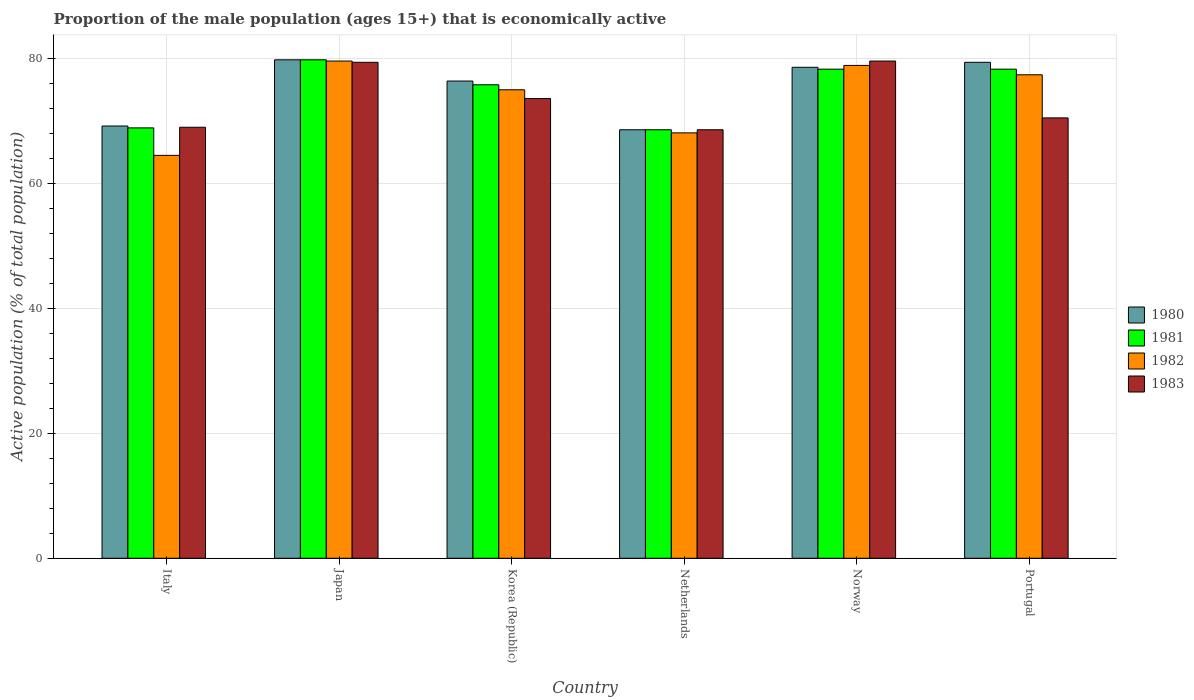How many groups of bars are there?
Offer a very short reply. 6. What is the label of the 6th group of bars from the left?
Make the answer very short. Portugal. In how many cases, is the number of bars for a given country not equal to the number of legend labels?
Ensure brevity in your answer.  0. What is the proportion of the male population that is economically active in 1981 in Norway?
Your response must be concise. 78.3. Across all countries, what is the maximum proportion of the male population that is economically active in 1981?
Offer a terse response. 79.8. Across all countries, what is the minimum proportion of the male population that is economically active in 1983?
Provide a short and direct response. 68.6. In which country was the proportion of the male population that is economically active in 1982 maximum?
Provide a short and direct response. Japan. What is the total proportion of the male population that is economically active in 1981 in the graph?
Ensure brevity in your answer.  449.7. What is the difference between the proportion of the male population that is economically active in 1983 in Italy and the proportion of the male population that is economically active in 1981 in Japan?
Provide a short and direct response. -10.8. What is the average proportion of the male population that is economically active in 1980 per country?
Ensure brevity in your answer.  75.33. What is the difference between the proportion of the male population that is economically active of/in 1980 and proportion of the male population that is economically active of/in 1983 in Norway?
Offer a terse response. -1. In how many countries, is the proportion of the male population that is economically active in 1983 greater than 40 %?
Your answer should be compact. 6. What is the ratio of the proportion of the male population that is economically active in 1981 in Italy to that in Norway?
Your answer should be compact. 0.88. Is the proportion of the male population that is economically active in 1980 in Norway less than that in Portugal?
Give a very brief answer. Yes. Is the difference between the proportion of the male population that is economically active in 1980 in Japan and Portugal greater than the difference between the proportion of the male population that is economically active in 1983 in Japan and Portugal?
Give a very brief answer. No. What is the difference between the highest and the second highest proportion of the male population that is economically active in 1982?
Your answer should be compact. -1.5. What is the difference between the highest and the lowest proportion of the male population that is economically active in 1983?
Make the answer very short. 11. Is the sum of the proportion of the male population that is economically active in 1981 in Japan and Netherlands greater than the maximum proportion of the male population that is economically active in 1982 across all countries?
Ensure brevity in your answer.  Yes. What does the 1st bar from the left in Korea (Republic) represents?
Provide a succinct answer. 1980. Is it the case that in every country, the sum of the proportion of the male population that is economically active in 1982 and proportion of the male population that is economically active in 1983 is greater than the proportion of the male population that is economically active in 1980?
Ensure brevity in your answer.  Yes. How many bars are there?
Keep it short and to the point. 24. Are all the bars in the graph horizontal?
Make the answer very short. No. What is the difference between two consecutive major ticks on the Y-axis?
Make the answer very short. 20. Are the values on the major ticks of Y-axis written in scientific E-notation?
Your response must be concise. No. Does the graph contain any zero values?
Your answer should be very brief. No. Does the graph contain grids?
Ensure brevity in your answer.  Yes. Where does the legend appear in the graph?
Offer a very short reply. Center right. What is the title of the graph?
Your answer should be compact. Proportion of the male population (ages 15+) that is economically active. Does "1972" appear as one of the legend labels in the graph?
Keep it short and to the point. No. What is the label or title of the Y-axis?
Keep it short and to the point. Active population (% of total population). What is the Active population (% of total population) in 1980 in Italy?
Offer a terse response. 69.2. What is the Active population (% of total population) of 1981 in Italy?
Your answer should be compact. 68.9. What is the Active population (% of total population) in 1982 in Italy?
Provide a succinct answer. 64.5. What is the Active population (% of total population) of 1983 in Italy?
Offer a terse response. 69. What is the Active population (% of total population) of 1980 in Japan?
Your answer should be very brief. 79.8. What is the Active population (% of total population) in 1981 in Japan?
Your response must be concise. 79.8. What is the Active population (% of total population) of 1982 in Japan?
Keep it short and to the point. 79.6. What is the Active population (% of total population) of 1983 in Japan?
Keep it short and to the point. 79.4. What is the Active population (% of total population) in 1980 in Korea (Republic)?
Offer a very short reply. 76.4. What is the Active population (% of total population) in 1981 in Korea (Republic)?
Make the answer very short. 75.8. What is the Active population (% of total population) of 1983 in Korea (Republic)?
Give a very brief answer. 73.6. What is the Active population (% of total population) of 1980 in Netherlands?
Your answer should be compact. 68.6. What is the Active population (% of total population) in 1981 in Netherlands?
Make the answer very short. 68.6. What is the Active population (% of total population) in 1982 in Netherlands?
Give a very brief answer. 68.1. What is the Active population (% of total population) of 1983 in Netherlands?
Provide a succinct answer. 68.6. What is the Active population (% of total population) in 1980 in Norway?
Your answer should be compact. 78.6. What is the Active population (% of total population) in 1981 in Norway?
Your answer should be compact. 78.3. What is the Active population (% of total population) in 1982 in Norway?
Keep it short and to the point. 78.9. What is the Active population (% of total population) in 1983 in Norway?
Offer a very short reply. 79.6. What is the Active population (% of total population) in 1980 in Portugal?
Your response must be concise. 79.4. What is the Active population (% of total population) of 1981 in Portugal?
Make the answer very short. 78.3. What is the Active population (% of total population) in 1982 in Portugal?
Keep it short and to the point. 77.4. What is the Active population (% of total population) in 1983 in Portugal?
Give a very brief answer. 70.5. Across all countries, what is the maximum Active population (% of total population) in 1980?
Keep it short and to the point. 79.8. Across all countries, what is the maximum Active population (% of total population) in 1981?
Provide a succinct answer. 79.8. Across all countries, what is the maximum Active population (% of total population) of 1982?
Your response must be concise. 79.6. Across all countries, what is the maximum Active population (% of total population) of 1983?
Offer a terse response. 79.6. Across all countries, what is the minimum Active population (% of total population) of 1980?
Your response must be concise. 68.6. Across all countries, what is the minimum Active population (% of total population) of 1981?
Offer a very short reply. 68.6. Across all countries, what is the minimum Active population (% of total population) in 1982?
Ensure brevity in your answer.  64.5. Across all countries, what is the minimum Active population (% of total population) in 1983?
Offer a very short reply. 68.6. What is the total Active population (% of total population) of 1980 in the graph?
Ensure brevity in your answer.  452. What is the total Active population (% of total population) in 1981 in the graph?
Provide a succinct answer. 449.7. What is the total Active population (% of total population) of 1982 in the graph?
Your response must be concise. 443.5. What is the total Active population (% of total population) of 1983 in the graph?
Give a very brief answer. 440.7. What is the difference between the Active population (% of total population) of 1981 in Italy and that in Japan?
Give a very brief answer. -10.9. What is the difference between the Active population (% of total population) of 1982 in Italy and that in Japan?
Offer a very short reply. -15.1. What is the difference between the Active population (% of total population) in 1983 in Italy and that in Japan?
Offer a very short reply. -10.4. What is the difference between the Active population (% of total population) of 1981 in Italy and that in Korea (Republic)?
Offer a very short reply. -6.9. What is the difference between the Active population (% of total population) in 1982 in Italy and that in Korea (Republic)?
Your answer should be compact. -10.5. What is the difference between the Active population (% of total population) of 1983 in Italy and that in Korea (Republic)?
Offer a terse response. -4.6. What is the difference between the Active population (% of total population) in 1980 in Italy and that in Netherlands?
Ensure brevity in your answer.  0.6. What is the difference between the Active population (% of total population) in 1981 in Italy and that in Netherlands?
Your response must be concise. 0.3. What is the difference between the Active population (% of total population) in 1982 in Italy and that in Netherlands?
Give a very brief answer. -3.6. What is the difference between the Active population (% of total population) of 1980 in Italy and that in Norway?
Ensure brevity in your answer.  -9.4. What is the difference between the Active population (% of total population) of 1981 in Italy and that in Norway?
Your answer should be compact. -9.4. What is the difference between the Active population (% of total population) in 1982 in Italy and that in Norway?
Ensure brevity in your answer.  -14.4. What is the difference between the Active population (% of total population) of 1983 in Italy and that in Norway?
Offer a very short reply. -10.6. What is the difference between the Active population (% of total population) in 1980 in Italy and that in Portugal?
Make the answer very short. -10.2. What is the difference between the Active population (% of total population) in 1981 in Italy and that in Portugal?
Ensure brevity in your answer.  -9.4. What is the difference between the Active population (% of total population) in 1981 in Japan and that in Korea (Republic)?
Provide a succinct answer. 4. What is the difference between the Active population (% of total population) of 1982 in Japan and that in Korea (Republic)?
Provide a short and direct response. 4.6. What is the difference between the Active population (% of total population) of 1980 in Japan and that in Netherlands?
Provide a short and direct response. 11.2. What is the difference between the Active population (% of total population) of 1981 in Japan and that in Netherlands?
Give a very brief answer. 11.2. What is the difference between the Active population (% of total population) in 1982 in Japan and that in Norway?
Offer a terse response. 0.7. What is the difference between the Active population (% of total population) in 1982 in Japan and that in Portugal?
Offer a terse response. 2.2. What is the difference between the Active population (% of total population) of 1980 in Korea (Republic) and that in Netherlands?
Provide a short and direct response. 7.8. What is the difference between the Active population (% of total population) of 1981 in Korea (Republic) and that in Netherlands?
Your answer should be compact. 7.2. What is the difference between the Active population (% of total population) in 1980 in Korea (Republic) and that in Norway?
Keep it short and to the point. -2.2. What is the difference between the Active population (% of total population) in 1980 in Korea (Republic) and that in Portugal?
Offer a terse response. -3. What is the difference between the Active population (% of total population) of 1981 in Korea (Republic) and that in Portugal?
Your answer should be compact. -2.5. What is the difference between the Active population (% of total population) of 1982 in Korea (Republic) and that in Portugal?
Provide a succinct answer. -2.4. What is the difference between the Active population (% of total population) of 1983 in Korea (Republic) and that in Portugal?
Offer a terse response. 3.1. What is the difference between the Active population (% of total population) of 1980 in Netherlands and that in Norway?
Ensure brevity in your answer.  -10. What is the difference between the Active population (% of total population) in 1982 in Netherlands and that in Norway?
Provide a succinct answer. -10.8. What is the difference between the Active population (% of total population) of 1983 in Netherlands and that in Norway?
Provide a short and direct response. -11. What is the difference between the Active population (% of total population) in 1980 in Netherlands and that in Portugal?
Your answer should be compact. -10.8. What is the difference between the Active population (% of total population) of 1982 in Netherlands and that in Portugal?
Offer a very short reply. -9.3. What is the difference between the Active population (% of total population) in 1983 in Netherlands and that in Portugal?
Ensure brevity in your answer.  -1.9. What is the difference between the Active population (% of total population) in 1982 in Norway and that in Portugal?
Ensure brevity in your answer.  1.5. What is the difference between the Active population (% of total population) of 1983 in Norway and that in Portugal?
Provide a succinct answer. 9.1. What is the difference between the Active population (% of total population) in 1980 in Italy and the Active population (% of total population) in 1981 in Japan?
Your answer should be compact. -10.6. What is the difference between the Active population (% of total population) in 1980 in Italy and the Active population (% of total population) in 1982 in Japan?
Your answer should be compact. -10.4. What is the difference between the Active population (% of total population) of 1980 in Italy and the Active population (% of total population) of 1983 in Japan?
Make the answer very short. -10.2. What is the difference between the Active population (% of total population) in 1981 in Italy and the Active population (% of total population) in 1982 in Japan?
Ensure brevity in your answer.  -10.7. What is the difference between the Active population (% of total population) of 1982 in Italy and the Active population (% of total population) of 1983 in Japan?
Your answer should be compact. -14.9. What is the difference between the Active population (% of total population) in 1980 in Italy and the Active population (% of total population) in 1983 in Korea (Republic)?
Make the answer very short. -4.4. What is the difference between the Active population (% of total population) of 1981 in Italy and the Active population (% of total population) of 1983 in Korea (Republic)?
Your response must be concise. -4.7. What is the difference between the Active population (% of total population) of 1982 in Italy and the Active population (% of total population) of 1983 in Korea (Republic)?
Your answer should be compact. -9.1. What is the difference between the Active population (% of total population) of 1980 in Italy and the Active population (% of total population) of 1981 in Netherlands?
Your answer should be very brief. 0.6. What is the difference between the Active population (% of total population) of 1980 in Italy and the Active population (% of total population) of 1982 in Netherlands?
Ensure brevity in your answer.  1.1. What is the difference between the Active population (% of total population) of 1980 in Italy and the Active population (% of total population) of 1983 in Netherlands?
Your answer should be very brief. 0.6. What is the difference between the Active population (% of total population) in 1982 in Italy and the Active population (% of total population) in 1983 in Netherlands?
Keep it short and to the point. -4.1. What is the difference between the Active population (% of total population) of 1980 in Italy and the Active population (% of total population) of 1982 in Norway?
Offer a very short reply. -9.7. What is the difference between the Active population (% of total population) of 1980 in Italy and the Active population (% of total population) of 1983 in Norway?
Keep it short and to the point. -10.4. What is the difference between the Active population (% of total population) of 1981 in Italy and the Active population (% of total population) of 1982 in Norway?
Offer a terse response. -10. What is the difference between the Active population (% of total population) of 1981 in Italy and the Active population (% of total population) of 1983 in Norway?
Offer a terse response. -10.7. What is the difference between the Active population (% of total population) of 1982 in Italy and the Active population (% of total population) of 1983 in Norway?
Your answer should be very brief. -15.1. What is the difference between the Active population (% of total population) of 1980 in Italy and the Active population (% of total population) of 1981 in Portugal?
Make the answer very short. -9.1. What is the difference between the Active population (% of total population) in 1980 in Italy and the Active population (% of total population) in 1982 in Portugal?
Offer a very short reply. -8.2. What is the difference between the Active population (% of total population) of 1980 in Italy and the Active population (% of total population) of 1983 in Portugal?
Offer a very short reply. -1.3. What is the difference between the Active population (% of total population) of 1981 in Italy and the Active population (% of total population) of 1982 in Portugal?
Offer a very short reply. -8.5. What is the difference between the Active population (% of total population) of 1980 in Japan and the Active population (% of total population) of 1981 in Korea (Republic)?
Make the answer very short. 4. What is the difference between the Active population (% of total population) of 1980 in Japan and the Active population (% of total population) of 1982 in Korea (Republic)?
Offer a very short reply. 4.8. What is the difference between the Active population (% of total population) in 1981 in Japan and the Active population (% of total population) in 1983 in Korea (Republic)?
Provide a succinct answer. 6.2. What is the difference between the Active population (% of total population) in 1980 in Japan and the Active population (% of total population) in 1981 in Netherlands?
Offer a very short reply. 11.2. What is the difference between the Active population (% of total population) in 1980 in Japan and the Active population (% of total population) in 1983 in Netherlands?
Ensure brevity in your answer.  11.2. What is the difference between the Active population (% of total population) in 1981 in Japan and the Active population (% of total population) in 1982 in Netherlands?
Give a very brief answer. 11.7. What is the difference between the Active population (% of total population) in 1980 in Japan and the Active population (% of total population) in 1981 in Norway?
Ensure brevity in your answer.  1.5. What is the difference between the Active population (% of total population) of 1980 in Japan and the Active population (% of total population) of 1982 in Norway?
Your answer should be compact. 0.9. What is the difference between the Active population (% of total population) of 1980 in Japan and the Active population (% of total population) of 1983 in Norway?
Provide a short and direct response. 0.2. What is the difference between the Active population (% of total population) in 1980 in Japan and the Active population (% of total population) in 1981 in Portugal?
Give a very brief answer. 1.5. What is the difference between the Active population (% of total population) of 1980 in Japan and the Active population (% of total population) of 1982 in Portugal?
Keep it short and to the point. 2.4. What is the difference between the Active population (% of total population) of 1980 in Japan and the Active population (% of total population) of 1983 in Portugal?
Give a very brief answer. 9.3. What is the difference between the Active population (% of total population) of 1981 in Japan and the Active population (% of total population) of 1982 in Portugal?
Provide a short and direct response. 2.4. What is the difference between the Active population (% of total population) of 1982 in Japan and the Active population (% of total population) of 1983 in Portugal?
Your answer should be compact. 9.1. What is the difference between the Active population (% of total population) in 1980 in Korea (Republic) and the Active population (% of total population) in 1981 in Netherlands?
Keep it short and to the point. 7.8. What is the difference between the Active population (% of total population) of 1980 in Korea (Republic) and the Active population (% of total population) of 1982 in Netherlands?
Ensure brevity in your answer.  8.3. What is the difference between the Active population (% of total population) of 1980 in Korea (Republic) and the Active population (% of total population) of 1983 in Netherlands?
Your answer should be very brief. 7.8. What is the difference between the Active population (% of total population) of 1980 in Korea (Republic) and the Active population (% of total population) of 1982 in Norway?
Provide a succinct answer. -2.5. What is the difference between the Active population (% of total population) of 1981 in Korea (Republic) and the Active population (% of total population) of 1983 in Norway?
Provide a short and direct response. -3.8. What is the difference between the Active population (% of total population) in 1982 in Korea (Republic) and the Active population (% of total population) in 1983 in Norway?
Your response must be concise. -4.6. What is the difference between the Active population (% of total population) in 1980 in Korea (Republic) and the Active population (% of total population) in 1981 in Portugal?
Offer a terse response. -1.9. What is the difference between the Active population (% of total population) of 1980 in Korea (Republic) and the Active population (% of total population) of 1983 in Portugal?
Keep it short and to the point. 5.9. What is the difference between the Active population (% of total population) of 1981 in Korea (Republic) and the Active population (% of total population) of 1982 in Portugal?
Your answer should be compact. -1.6. What is the difference between the Active population (% of total population) of 1980 in Netherlands and the Active population (% of total population) of 1981 in Norway?
Ensure brevity in your answer.  -9.7. What is the difference between the Active population (% of total population) of 1981 in Netherlands and the Active population (% of total population) of 1983 in Norway?
Ensure brevity in your answer.  -11. What is the difference between the Active population (% of total population) of 1980 in Netherlands and the Active population (% of total population) of 1983 in Portugal?
Provide a short and direct response. -1.9. What is the difference between the Active population (% of total population) of 1981 in Netherlands and the Active population (% of total population) of 1982 in Portugal?
Your answer should be very brief. -8.8. What is the difference between the Active population (% of total population) in 1982 in Netherlands and the Active population (% of total population) in 1983 in Portugal?
Give a very brief answer. -2.4. What is the difference between the Active population (% of total population) in 1980 in Norway and the Active population (% of total population) in 1981 in Portugal?
Offer a terse response. 0.3. What is the difference between the Active population (% of total population) of 1980 in Norway and the Active population (% of total population) of 1982 in Portugal?
Offer a very short reply. 1.2. What is the difference between the Active population (% of total population) in 1982 in Norway and the Active population (% of total population) in 1983 in Portugal?
Make the answer very short. 8.4. What is the average Active population (% of total population) of 1980 per country?
Keep it short and to the point. 75.33. What is the average Active population (% of total population) of 1981 per country?
Offer a terse response. 74.95. What is the average Active population (% of total population) of 1982 per country?
Give a very brief answer. 73.92. What is the average Active population (% of total population) in 1983 per country?
Your answer should be very brief. 73.45. What is the difference between the Active population (% of total population) of 1980 and Active population (% of total population) of 1981 in Italy?
Give a very brief answer. 0.3. What is the difference between the Active population (% of total population) of 1980 and Active population (% of total population) of 1983 in Italy?
Offer a terse response. 0.2. What is the difference between the Active population (% of total population) of 1981 and Active population (% of total population) of 1982 in Italy?
Keep it short and to the point. 4.4. What is the difference between the Active population (% of total population) in 1981 and Active population (% of total population) in 1983 in Italy?
Provide a succinct answer. -0.1. What is the difference between the Active population (% of total population) in 1980 and Active population (% of total population) in 1982 in Japan?
Make the answer very short. 0.2. What is the difference between the Active population (% of total population) of 1980 and Active population (% of total population) of 1983 in Japan?
Make the answer very short. 0.4. What is the difference between the Active population (% of total population) in 1981 and Active population (% of total population) in 1982 in Japan?
Give a very brief answer. 0.2. What is the difference between the Active population (% of total population) of 1981 and Active population (% of total population) of 1983 in Japan?
Ensure brevity in your answer.  0.4. What is the difference between the Active population (% of total population) of 1981 and Active population (% of total population) of 1982 in Korea (Republic)?
Offer a very short reply. 0.8. What is the difference between the Active population (% of total population) of 1980 and Active population (% of total population) of 1983 in Netherlands?
Offer a very short reply. 0. What is the difference between the Active population (% of total population) of 1981 and Active population (% of total population) of 1983 in Netherlands?
Your response must be concise. 0. What is the difference between the Active population (% of total population) in 1980 and Active population (% of total population) in 1981 in Norway?
Your answer should be very brief. 0.3. What is the difference between the Active population (% of total population) in 1981 and Active population (% of total population) in 1982 in Norway?
Ensure brevity in your answer.  -0.6. What is the difference between the Active population (% of total population) of 1982 and Active population (% of total population) of 1983 in Norway?
Provide a short and direct response. -0.7. What is the difference between the Active population (% of total population) of 1980 and Active population (% of total population) of 1981 in Portugal?
Make the answer very short. 1.1. What is the difference between the Active population (% of total population) in 1982 and Active population (% of total population) in 1983 in Portugal?
Ensure brevity in your answer.  6.9. What is the ratio of the Active population (% of total population) of 1980 in Italy to that in Japan?
Your answer should be compact. 0.87. What is the ratio of the Active population (% of total population) of 1981 in Italy to that in Japan?
Provide a succinct answer. 0.86. What is the ratio of the Active population (% of total population) in 1982 in Italy to that in Japan?
Give a very brief answer. 0.81. What is the ratio of the Active population (% of total population) of 1983 in Italy to that in Japan?
Your answer should be compact. 0.87. What is the ratio of the Active population (% of total population) in 1980 in Italy to that in Korea (Republic)?
Make the answer very short. 0.91. What is the ratio of the Active population (% of total population) of 1981 in Italy to that in Korea (Republic)?
Your response must be concise. 0.91. What is the ratio of the Active population (% of total population) in 1982 in Italy to that in Korea (Republic)?
Ensure brevity in your answer.  0.86. What is the ratio of the Active population (% of total population) in 1980 in Italy to that in Netherlands?
Make the answer very short. 1.01. What is the ratio of the Active population (% of total population) in 1981 in Italy to that in Netherlands?
Provide a succinct answer. 1. What is the ratio of the Active population (% of total population) of 1982 in Italy to that in Netherlands?
Provide a succinct answer. 0.95. What is the ratio of the Active population (% of total population) of 1983 in Italy to that in Netherlands?
Your answer should be very brief. 1.01. What is the ratio of the Active population (% of total population) of 1980 in Italy to that in Norway?
Make the answer very short. 0.88. What is the ratio of the Active population (% of total population) in 1981 in Italy to that in Norway?
Keep it short and to the point. 0.88. What is the ratio of the Active population (% of total population) of 1982 in Italy to that in Norway?
Your answer should be very brief. 0.82. What is the ratio of the Active population (% of total population) in 1983 in Italy to that in Norway?
Keep it short and to the point. 0.87. What is the ratio of the Active population (% of total population) in 1980 in Italy to that in Portugal?
Your answer should be compact. 0.87. What is the ratio of the Active population (% of total population) of 1981 in Italy to that in Portugal?
Make the answer very short. 0.88. What is the ratio of the Active population (% of total population) in 1982 in Italy to that in Portugal?
Your answer should be compact. 0.83. What is the ratio of the Active population (% of total population) in 1983 in Italy to that in Portugal?
Your response must be concise. 0.98. What is the ratio of the Active population (% of total population) of 1980 in Japan to that in Korea (Republic)?
Make the answer very short. 1.04. What is the ratio of the Active population (% of total population) of 1981 in Japan to that in Korea (Republic)?
Give a very brief answer. 1.05. What is the ratio of the Active population (% of total population) of 1982 in Japan to that in Korea (Republic)?
Give a very brief answer. 1.06. What is the ratio of the Active population (% of total population) of 1983 in Japan to that in Korea (Republic)?
Offer a terse response. 1.08. What is the ratio of the Active population (% of total population) in 1980 in Japan to that in Netherlands?
Your answer should be very brief. 1.16. What is the ratio of the Active population (% of total population) of 1981 in Japan to that in Netherlands?
Provide a succinct answer. 1.16. What is the ratio of the Active population (% of total population) of 1982 in Japan to that in Netherlands?
Keep it short and to the point. 1.17. What is the ratio of the Active population (% of total population) in 1983 in Japan to that in Netherlands?
Your answer should be very brief. 1.16. What is the ratio of the Active population (% of total population) in 1980 in Japan to that in Norway?
Ensure brevity in your answer.  1.02. What is the ratio of the Active population (% of total population) in 1981 in Japan to that in Norway?
Make the answer very short. 1.02. What is the ratio of the Active population (% of total population) in 1982 in Japan to that in Norway?
Your answer should be compact. 1.01. What is the ratio of the Active population (% of total population) in 1983 in Japan to that in Norway?
Give a very brief answer. 1. What is the ratio of the Active population (% of total population) in 1981 in Japan to that in Portugal?
Keep it short and to the point. 1.02. What is the ratio of the Active population (% of total population) in 1982 in Japan to that in Portugal?
Keep it short and to the point. 1.03. What is the ratio of the Active population (% of total population) in 1983 in Japan to that in Portugal?
Provide a succinct answer. 1.13. What is the ratio of the Active population (% of total population) of 1980 in Korea (Republic) to that in Netherlands?
Give a very brief answer. 1.11. What is the ratio of the Active population (% of total population) of 1981 in Korea (Republic) to that in Netherlands?
Your answer should be very brief. 1.1. What is the ratio of the Active population (% of total population) in 1982 in Korea (Republic) to that in Netherlands?
Give a very brief answer. 1.1. What is the ratio of the Active population (% of total population) in 1983 in Korea (Republic) to that in Netherlands?
Your answer should be compact. 1.07. What is the ratio of the Active population (% of total population) of 1981 in Korea (Republic) to that in Norway?
Your answer should be very brief. 0.97. What is the ratio of the Active population (% of total population) of 1982 in Korea (Republic) to that in Norway?
Your answer should be compact. 0.95. What is the ratio of the Active population (% of total population) in 1983 in Korea (Republic) to that in Norway?
Offer a very short reply. 0.92. What is the ratio of the Active population (% of total population) in 1980 in Korea (Republic) to that in Portugal?
Your answer should be compact. 0.96. What is the ratio of the Active population (% of total population) of 1981 in Korea (Republic) to that in Portugal?
Your response must be concise. 0.97. What is the ratio of the Active population (% of total population) of 1982 in Korea (Republic) to that in Portugal?
Offer a very short reply. 0.97. What is the ratio of the Active population (% of total population) of 1983 in Korea (Republic) to that in Portugal?
Offer a terse response. 1.04. What is the ratio of the Active population (% of total population) of 1980 in Netherlands to that in Norway?
Make the answer very short. 0.87. What is the ratio of the Active population (% of total population) in 1981 in Netherlands to that in Norway?
Offer a terse response. 0.88. What is the ratio of the Active population (% of total population) in 1982 in Netherlands to that in Norway?
Provide a short and direct response. 0.86. What is the ratio of the Active population (% of total population) in 1983 in Netherlands to that in Norway?
Your response must be concise. 0.86. What is the ratio of the Active population (% of total population) of 1980 in Netherlands to that in Portugal?
Provide a succinct answer. 0.86. What is the ratio of the Active population (% of total population) of 1981 in Netherlands to that in Portugal?
Your response must be concise. 0.88. What is the ratio of the Active population (% of total population) in 1982 in Netherlands to that in Portugal?
Give a very brief answer. 0.88. What is the ratio of the Active population (% of total population) of 1983 in Netherlands to that in Portugal?
Ensure brevity in your answer.  0.97. What is the ratio of the Active population (% of total population) of 1982 in Norway to that in Portugal?
Offer a very short reply. 1.02. What is the ratio of the Active population (% of total population) of 1983 in Norway to that in Portugal?
Provide a succinct answer. 1.13. What is the difference between the highest and the second highest Active population (% of total population) of 1981?
Offer a terse response. 1.5. What is the difference between the highest and the second highest Active population (% of total population) in 1982?
Provide a succinct answer. 0.7. What is the difference between the highest and the lowest Active population (% of total population) in 1981?
Keep it short and to the point. 11.2. What is the difference between the highest and the lowest Active population (% of total population) of 1983?
Provide a short and direct response. 11. 